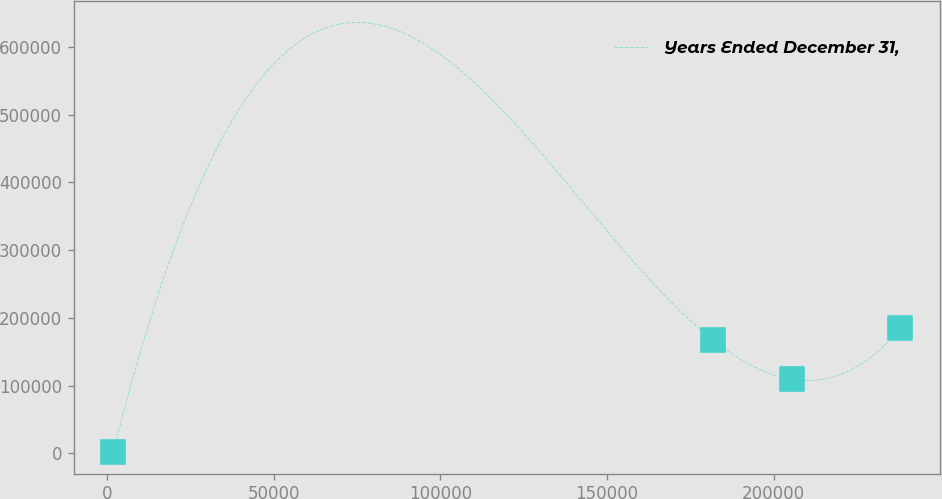Convert chart to OTSL. <chart><loc_0><loc_0><loc_500><loc_500><line_chart><ecel><fcel>Years Ended December 31,<nl><fcel>1858.44<fcel>1855.91<nl><fcel>181784<fcel>167206<nl><fcel>205396<fcel>109217<nl><fcel>237978<fcel>184472<nl></chart> 